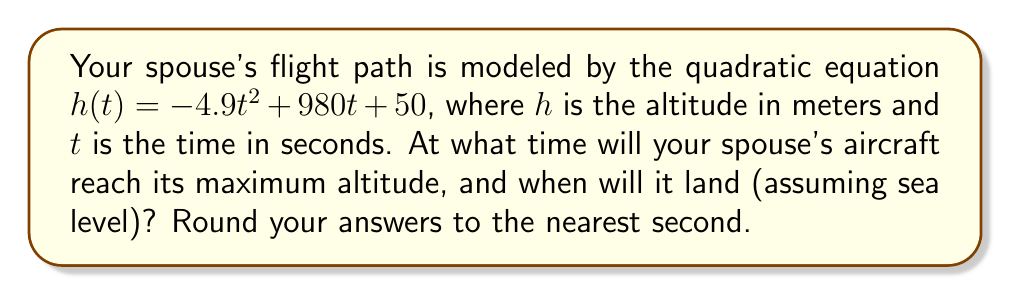Help me with this question. 1. To find the time of maximum altitude:
   The vertex of a parabola represents the maximum point for an upward-facing parabola or the minimum for a downward-facing parabola.
   For a quadratic equation in the form $ax^2 + bx + c$, the x-coordinate of the vertex is given by $-b/(2a)$.
   Here, $a = -4.9$, $b = 980$
   Time of max altitude = $-980 / (2(-4.9)) = 980 / 9.8 = 100$ seconds

2. To find the landing time:
   We need to solve $h(t) = 0$
   $-4.9t^2 + 980t + 50 = 0$
   
   Using the quadratic formula: $t = \frac{-b \pm \sqrt{b^2 - 4ac}}{2a}$
   
   $t = \frac{-980 \pm \sqrt{980^2 - 4(-4.9)(50)}}{2(-4.9)}$
   
   $t = \frac{-980 \pm \sqrt{960400 + 980}}{-9.8}$
   
   $t = \frac{-980 \pm \sqrt{961380}}{-9.8}$
   
   $t = \frac{-980 \pm 980.5}{-9.8}$
   
   This gives us two solutions:
   $t_1 = \frac{-980 + 980.5}{-9.8} \approx 0.05$ seconds (not relevant as it's before takeoff)
   $t_2 = \frac{-980 - 980.5}{-9.8} \approx 200.05$ seconds

Rounding to the nearest second:
Time of max altitude: 100 seconds
Landing time: 200 seconds
Answer: Max altitude at 100 s, landing at 200 s 